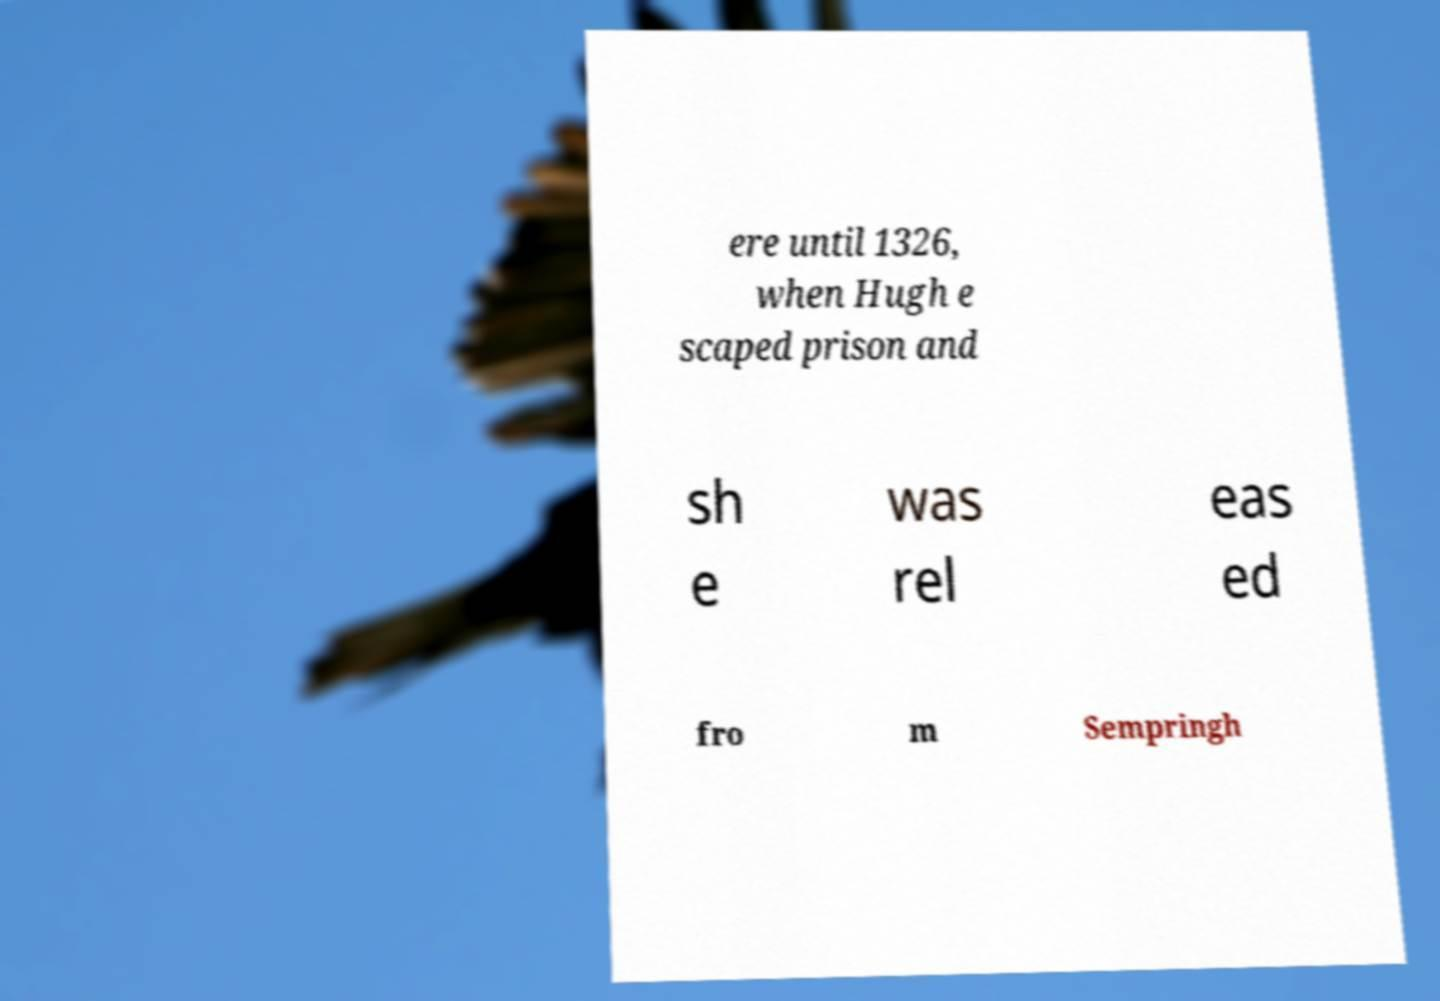Could you assist in decoding the text presented in this image and type it out clearly? ere until 1326, when Hugh e scaped prison and sh e was rel eas ed fro m Sempringh 